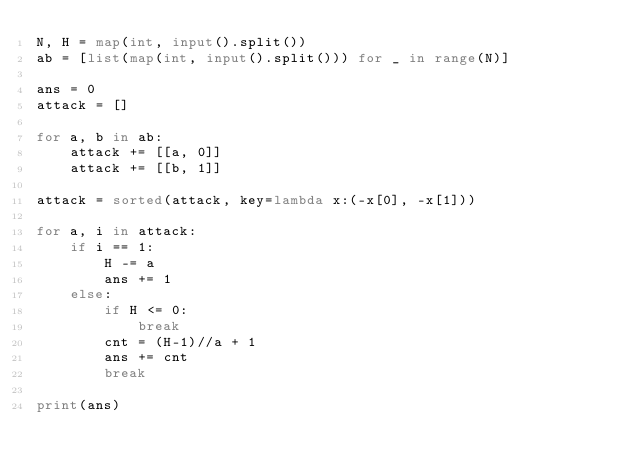<code> <loc_0><loc_0><loc_500><loc_500><_Python_>N, H = map(int, input().split())
ab = [list(map(int, input().split())) for _ in range(N)]

ans = 0
attack = []

for a, b in ab:
    attack += [[a, 0]]
    attack += [[b, 1]]

attack = sorted(attack, key=lambda x:(-x[0], -x[1]))

for a, i in attack:
    if i == 1:
        H -= a
        ans += 1
    else:
        if H <= 0:
            break
        cnt = (H-1)//a + 1
        ans += cnt
        break

print(ans)</code> 